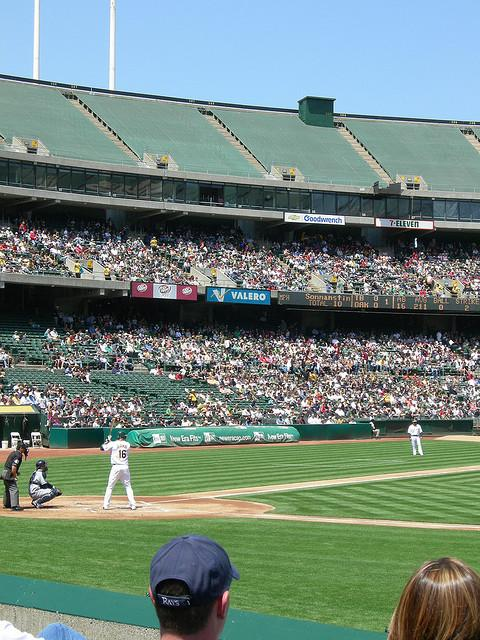The man wearing what color of shirt enforces the rules of the game?

Choices:
A) grey
B) white
C) red
D) black black 